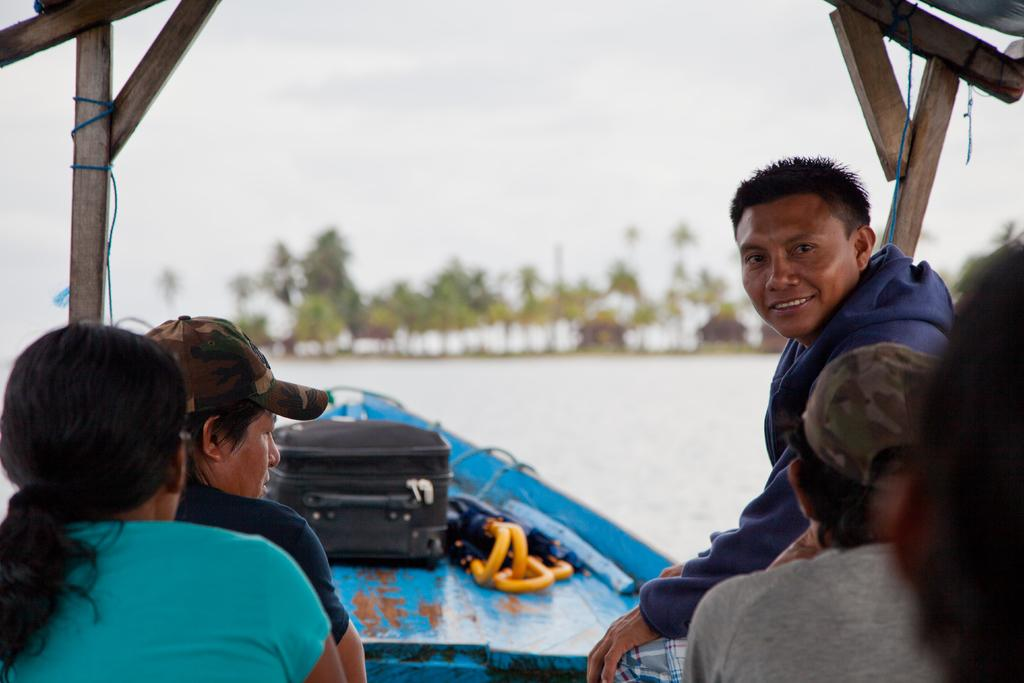What are the people in the image doing? The people are sitting on a boat in the image. What can be seen in the background of the image? There are trees in the background of the image. What is visible at the top of the image? The sky is visible at the top of the image. Can you tell me how many earthquakes are happening in the image? There are no earthquakes present in the image. What type of coal can be seen in the mouth of the person sitting on the boat? There is no coal or person with a mouth visible in the image. 